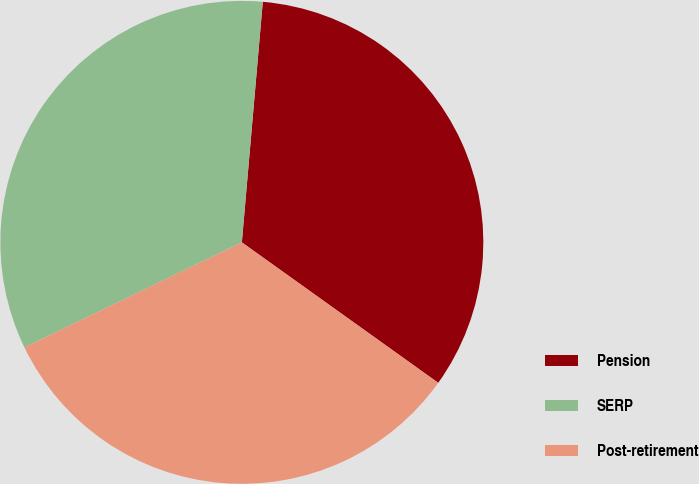Convert chart to OTSL. <chart><loc_0><loc_0><loc_500><loc_500><pie_chart><fcel>Pension<fcel>SERP<fcel>Post-retirement<nl><fcel>33.5%<fcel>33.55%<fcel>32.95%<nl></chart> 